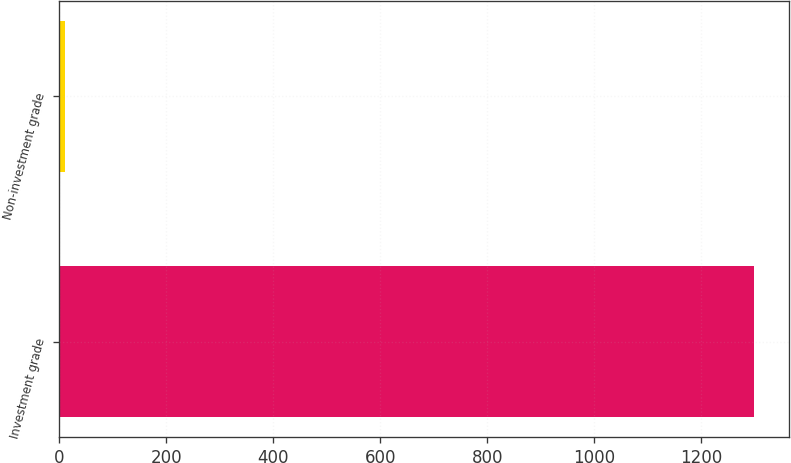Convert chart to OTSL. <chart><loc_0><loc_0><loc_500><loc_500><bar_chart><fcel>Investment grade<fcel>Non-investment grade<nl><fcel>1299<fcel>11<nl></chart> 